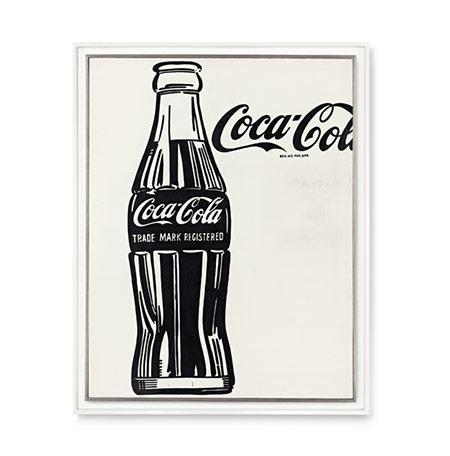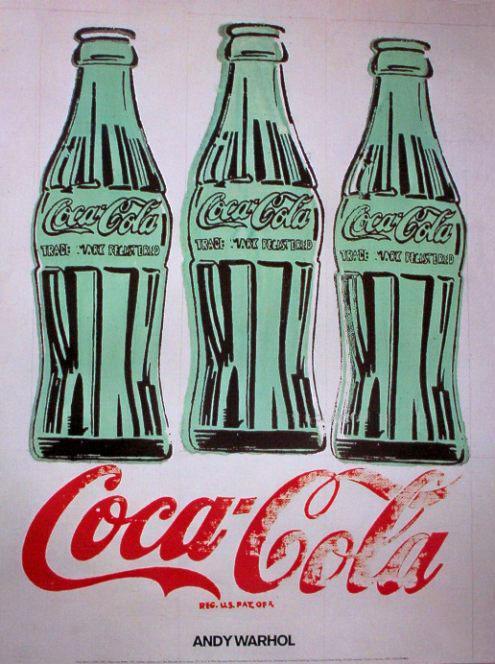The first image is the image on the left, the second image is the image on the right. For the images shown, is this caption "The artwork in the image on the right depicts exactly three bottles." true? Answer yes or no. Yes. The first image is the image on the left, the second image is the image on the right. Evaluate the accuracy of this statement regarding the images: "There are four bottles of soda.". Is it true? Answer yes or no. Yes. 